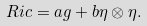<formula> <loc_0><loc_0><loc_500><loc_500>R i c = a g + b \eta \otimes \eta .</formula> 